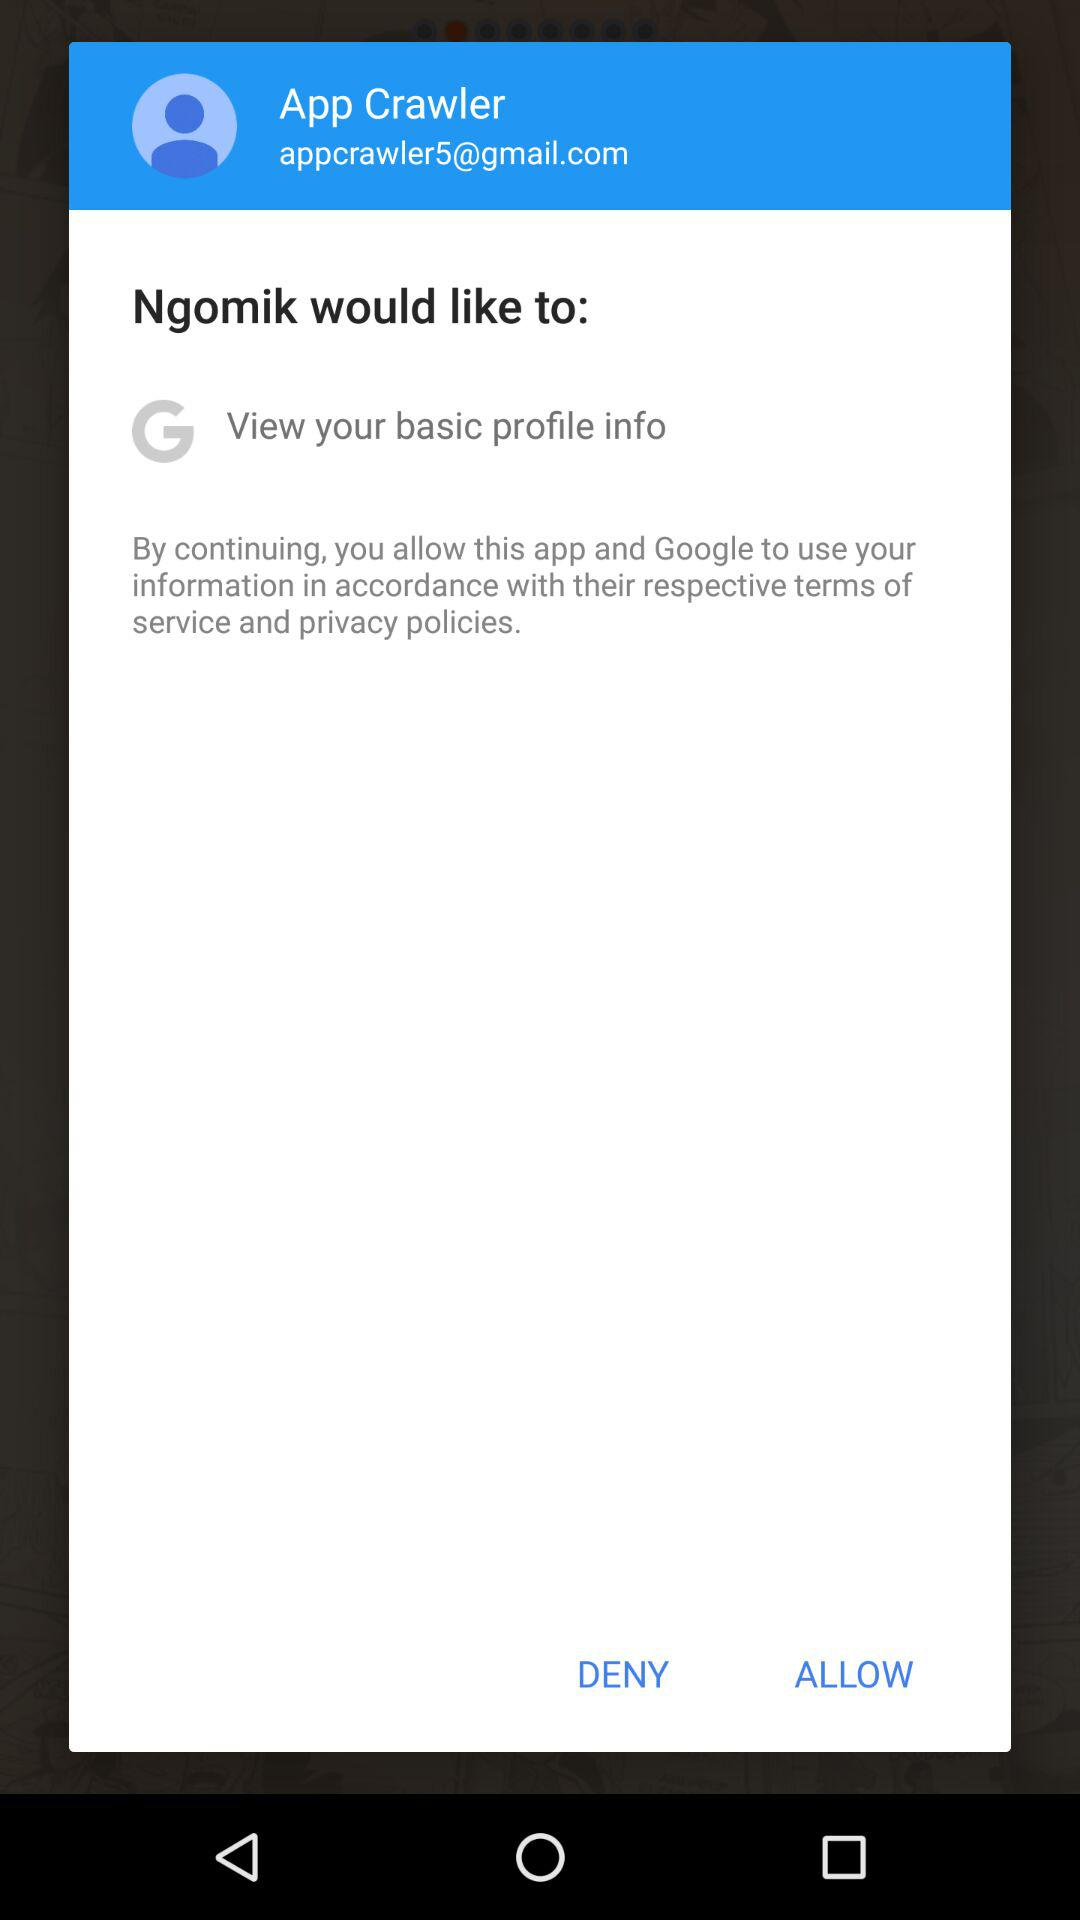What is the user name? The user name is App Crawler. 